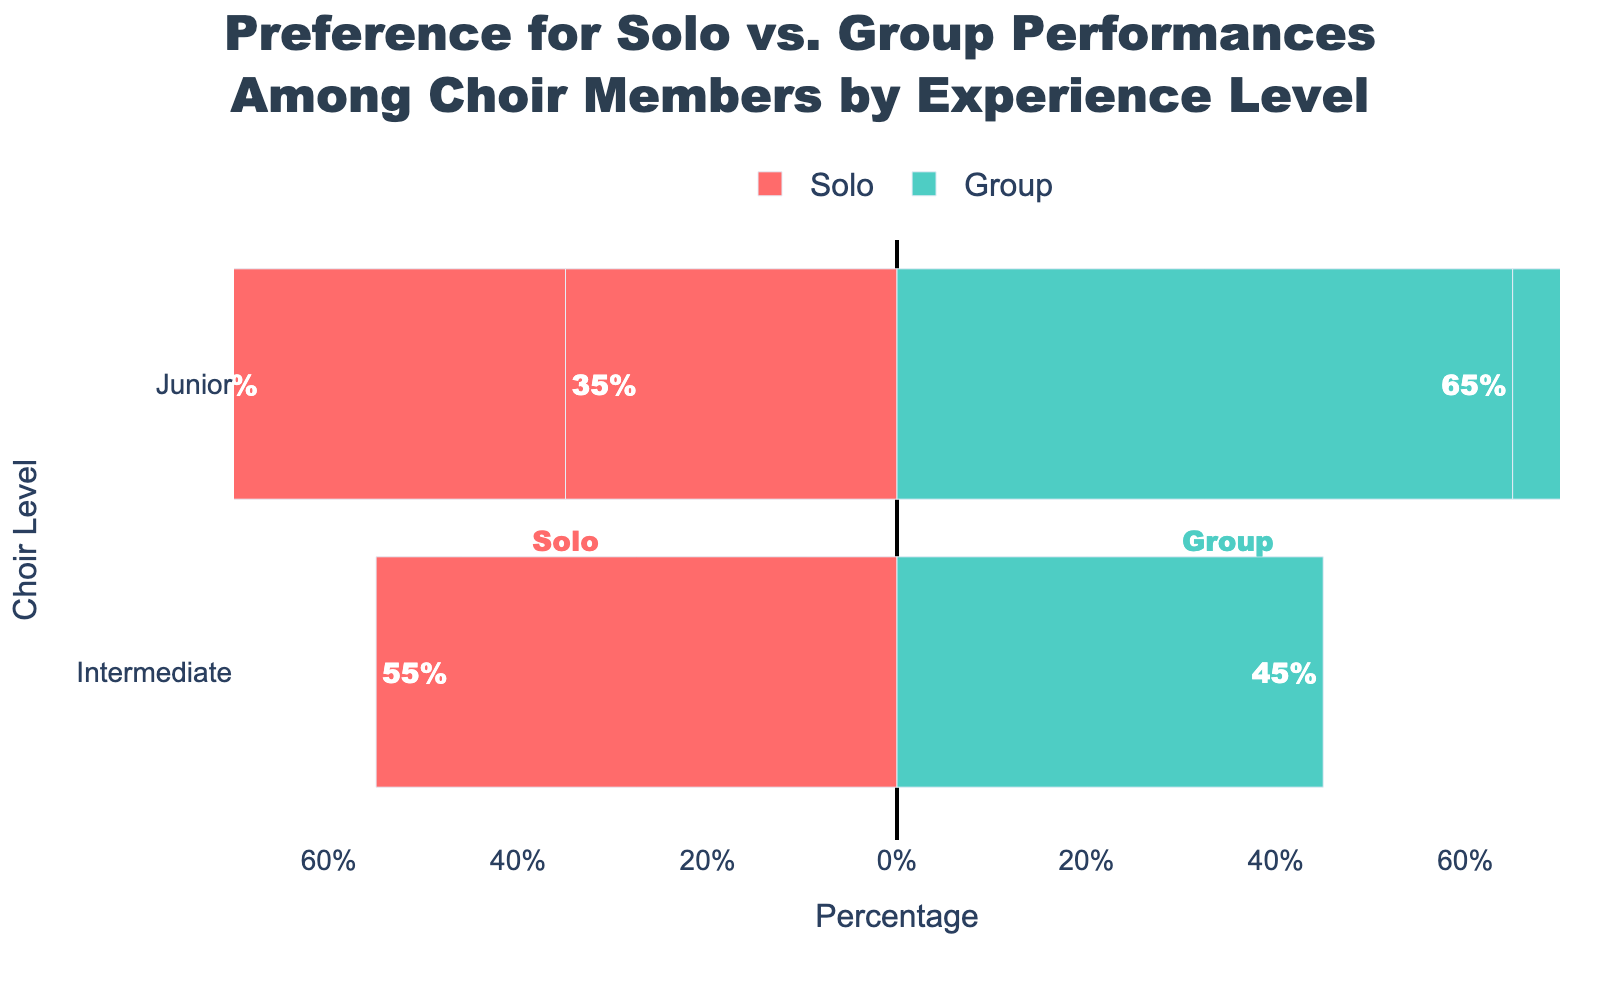Which choir level has the highest preference for solo performances? The Senior level shows a higher preference for solo performances with a percentage of 55%, compared to Intermediate at 40% and Junior at 35%.
Answer: Senior What is the total percentage of Junior choir members who favor either solo or group performances? For Junior choir members, the sum of those favoring solo (35%) and group performances (65%) is 35% + 65%, which equals 100%.
Answer: 100% Is there a choir level where the preference for solo performances is greater than for group performances? By observing the bars, only the Senior choir level has a preference for solo performances (55%) that is greater than for group performances (45%).
Answer: Senior Which preference type has the highest percentage among Intermediate choir members? For Intermediate choir members, the green bar representing the group performances is longer than the red bar. Group performances have a 60% preference, while solo performances have 40%.
Answer: Group performances Compare the preference for group performances between Junior and Senior choir members. For group performances, Junior choir members have a 65% preference, while Senior choir members have a 45% preference. Therefore, Junior choir members have a higher preference for group performances compared to Senior members.
Answer: Junior members have a higher preference How do the preferences for solo performances change from Junior to Senior choir levels? The preference for solo performances increases from 35% in Junior choir members to 40% in Intermediate members, and further to 55% in Senior members.
Answer: It increases What is the difference in the percentage of members favoring solo performances between Intermediate and Senior levels? The difference is calculated as Senior (55%) - Intermediate (40%), which is 15%.
Answer: 15% What are the two types of preferences displayed in the chart and how are they visually distinguished? The chart displays preferences for solo and group performances. Solo performances are represented with red bars, while group performances are represented with green bars.
Answer: Solo (red) and Group (green) What is the average preference for solo performances across all choir levels? The percentages for solo performances are 35% (Junior), 40% (Intermediate), and 55% (Senior). The average is calculated as (35 + 40 + 55) / 3 = 43.33%.
Answer: 43.33% 